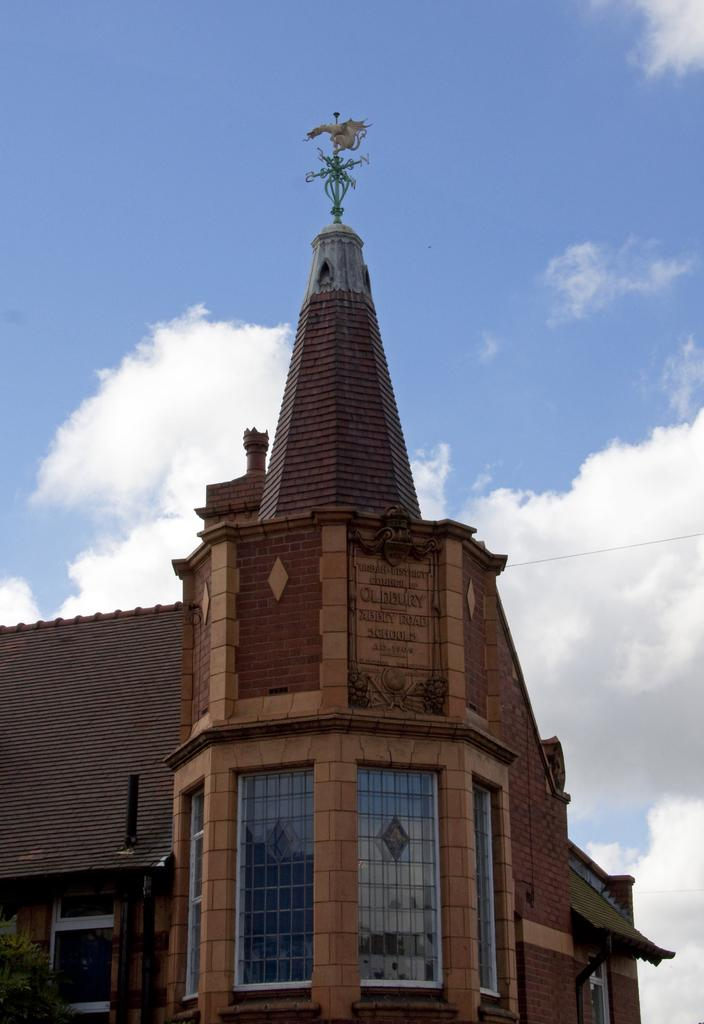What type of structure is present in the image? There is a building in the image. What is the color of the building? The building is brown in color. What can be seen in the background of the image? There are clouds and the sky visible in the background of the image. How many times did the building try to push the clouds away in the image? The building does not have the ability to push clouds away, as it is an inanimate object. 